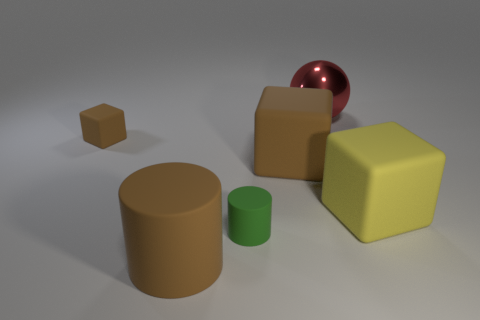Are there any other things that are the same shape as the small green matte thing?
Your response must be concise. Yes. There is a big brown rubber object that is in front of the large matte cube that is left of the red ball; what number of large spheres are right of it?
Ensure brevity in your answer.  1. There is a big red shiny ball; what number of metal balls are right of it?
Provide a short and direct response. 0. How many big brown objects have the same material as the large brown cylinder?
Your answer should be very brief. 1. The large cylinder that is the same material as the small brown cube is what color?
Ensure brevity in your answer.  Brown. The brown thing that is behind the big rubber block that is to the left of the large object that is behind the small matte block is made of what material?
Your answer should be compact. Rubber. Do the brown rubber object in front of the yellow object and the large yellow matte thing have the same size?
Offer a terse response. Yes. What number of tiny objects are either brown rubber things or green rubber objects?
Offer a terse response. 2. Is there a matte thing that has the same color as the large cylinder?
Offer a very short reply. Yes. The shiny thing that is the same size as the yellow block is what shape?
Offer a very short reply. Sphere. 